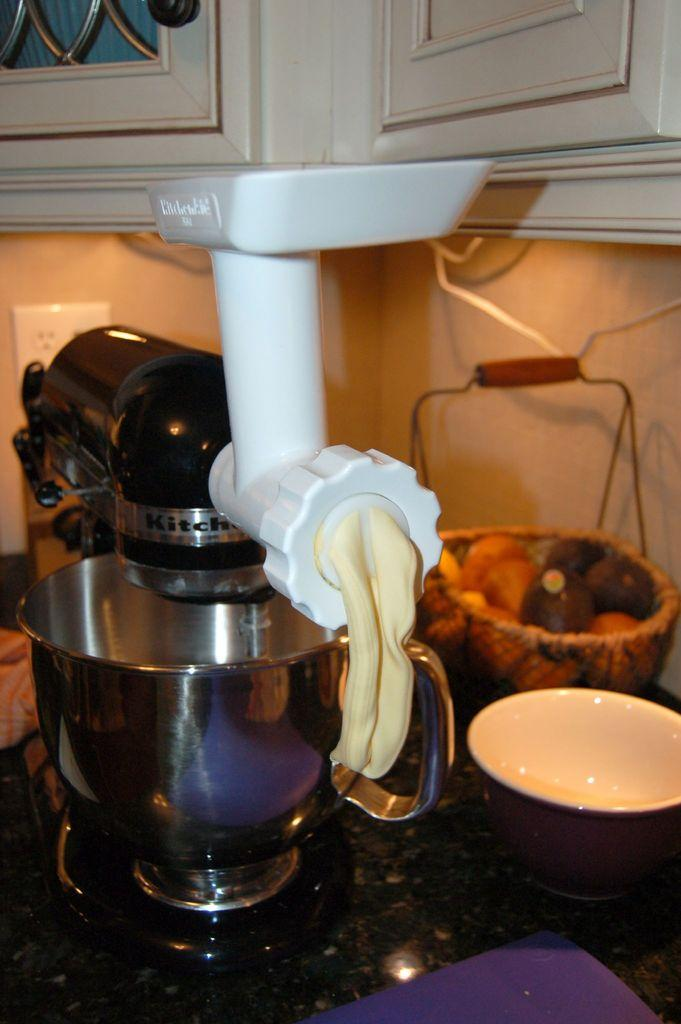<image>
Render a clear and concise summary of the photo. A kitchenaid cooking product on a kitchen counter. 